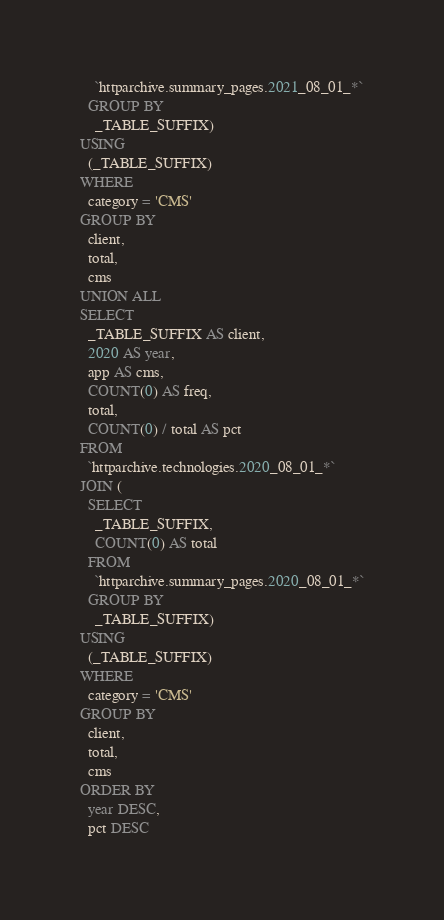Convert code to text. <code><loc_0><loc_0><loc_500><loc_500><_SQL_>    `httparchive.summary_pages.2021_08_01_*`
  GROUP BY
    _TABLE_SUFFIX)
USING
  (_TABLE_SUFFIX)
WHERE
  category = 'CMS'
GROUP BY
  client,
  total,
  cms
UNION ALL
SELECT
  _TABLE_SUFFIX AS client,
  2020 AS year,
  app AS cms,
  COUNT(0) AS freq,
  total,
  COUNT(0) / total AS pct
FROM
  `httparchive.technologies.2020_08_01_*`
JOIN (
  SELECT
    _TABLE_SUFFIX,
    COUNT(0) AS total
  FROM
    `httparchive.summary_pages.2020_08_01_*`
  GROUP BY
    _TABLE_SUFFIX)
USING
  (_TABLE_SUFFIX)
WHERE
  category = 'CMS'
GROUP BY
  client,
  total,
  cms
ORDER BY
  year DESC,
  pct DESC
</code> 